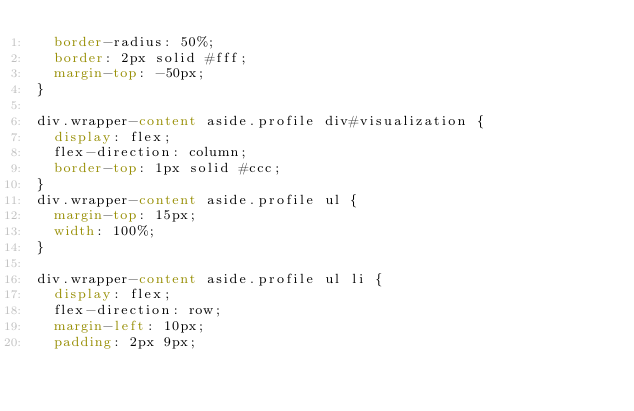Convert code to text. <code><loc_0><loc_0><loc_500><loc_500><_CSS_>  border-radius: 50%;
  border: 2px solid #fff;
  margin-top: -50px;
}

div.wrapper-content aside.profile div#visualization {
  display: flex;
  flex-direction: column;
  border-top: 1px solid #ccc;
}
div.wrapper-content aside.profile ul {
  margin-top: 15px;
  width: 100%;
}

div.wrapper-content aside.profile ul li {
  display: flex;
  flex-direction: row;
  margin-left: 10px;
  padding: 2px 9px;</code> 